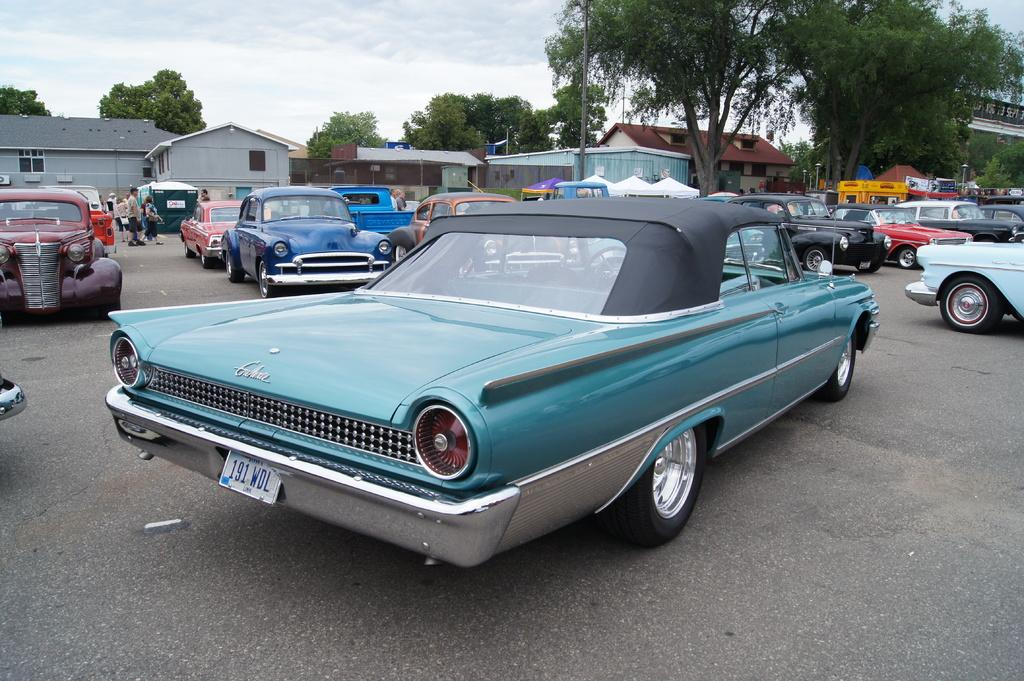What can be seen on the road in the image? There are fleets of cars on the road in the image. What is visible in the background of the image? In the background of the image, there are houses, trees, poles, and a bridge. What is visible at the top of the image? The sky is visible at the top of the image. When was the image taken? The image was taken during the day. What type of agreement is being signed on the bridge in the image? There is no agreement or people signing anything visible in the image; it only shows fleets of cars, houses, trees, poles, and a bridge in the background. What is the purpose of the tub in the image? There is no tub present in the image. 